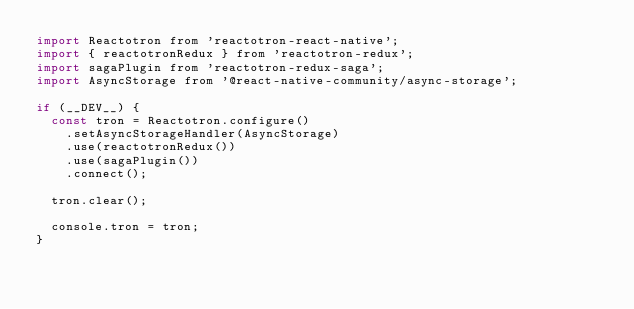<code> <loc_0><loc_0><loc_500><loc_500><_JavaScript_>import Reactotron from 'reactotron-react-native';
import { reactotronRedux } from 'reactotron-redux';
import sagaPlugin from 'reactotron-redux-saga';
import AsyncStorage from '@react-native-community/async-storage';

if (__DEV__) {
  const tron = Reactotron.configure()
    .setAsyncStorageHandler(AsyncStorage)
    .use(reactotronRedux())
    .use(sagaPlugin())
    .connect();

  tron.clear();

  console.tron = tron;
}
</code> 